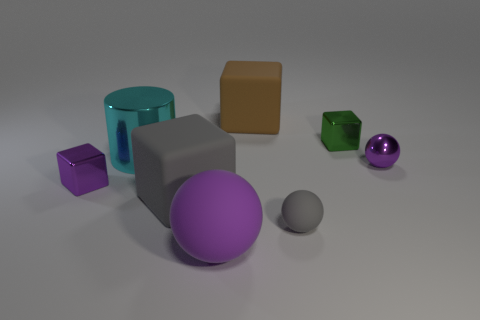There is a gray matte thing that is left of the large purple matte thing in front of the big shiny object; what is its size? The gray matte object to the left of the large purple ball and in front of the cylindrical item is relatively small in size compared to the other objects in the image, perhaps best described as medium-sized within this particular setting. 